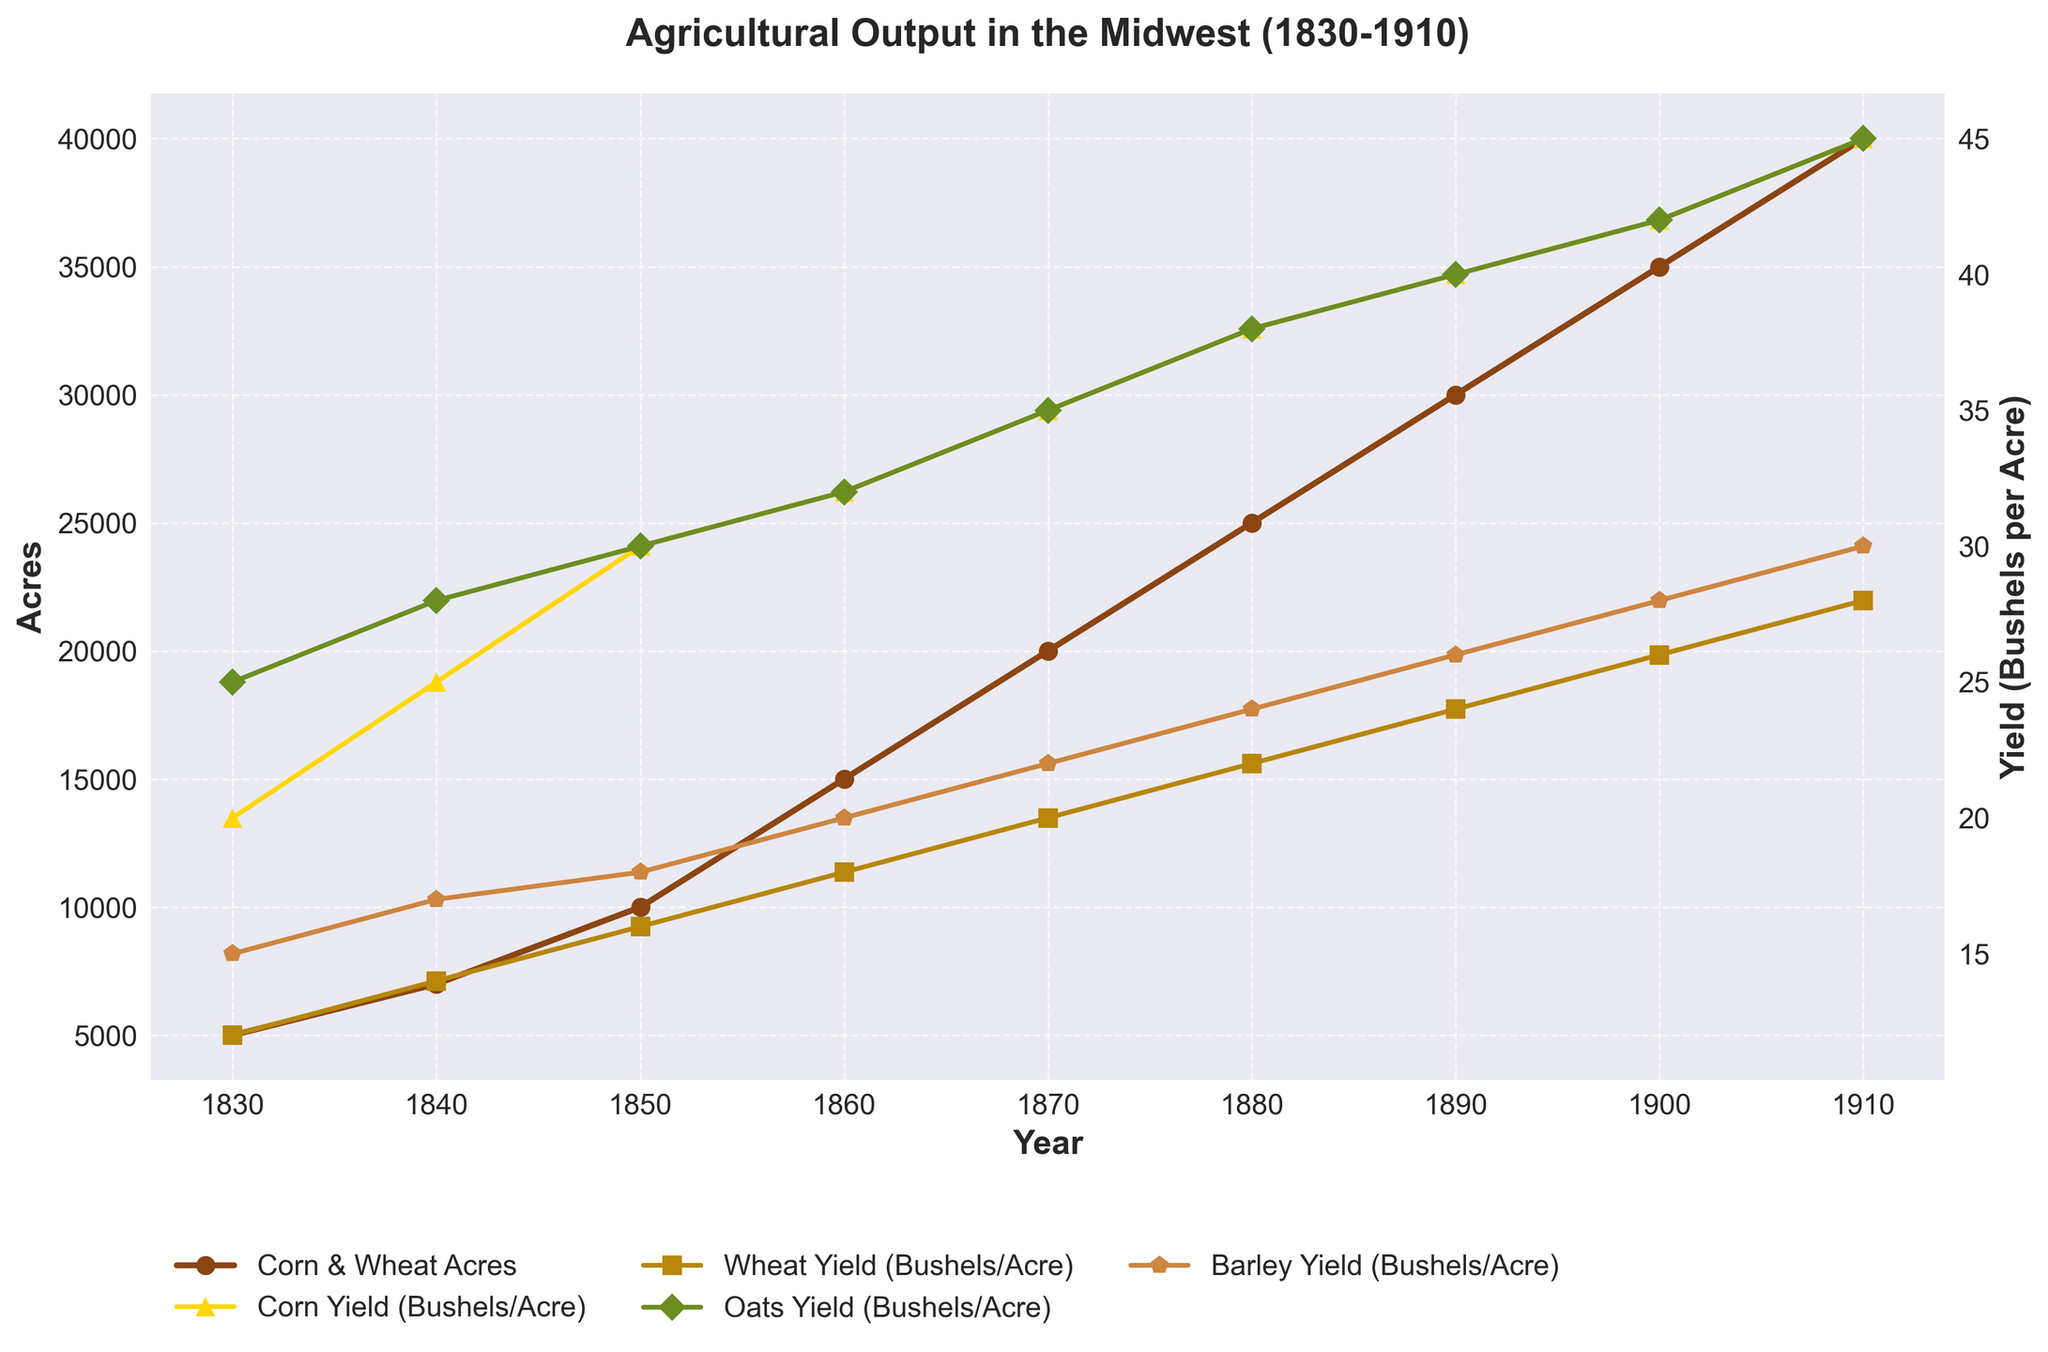What's the title of the figure? The title of the figure is prominently displayed at the top. The title is "Agricultural Output in the Midwest (1830-1910)".
Answer: Agricultural Output in the Midwest (1830-1910) How many acres were dedicated to Corn & Wheat in 1880? Look at the 'Corn & Wheat Acres' line and locate the year 1880 on the x-axis. Track vertically to find the corresponding y-value which is 25000 acres.
Answer: 25000 What were the yields of Corn and Wheat (in bushels per acre) in 1900? Track the curves for Corn Yield and Wheat Yield to the year 1900. The Corn Yield is 42 bushels per acre and the Wheat Yield is 26 bushels per acre.
Answer: Corn: 42, Wheat: 26 In which year did Oats Yield reach 45 bushels per acre? Follow the 'Oats Yield' line until it reaches 45 bushels per acre on the y-axis. This occurs in the year 1910.
Answer: 1910 Which crop had the highest yield in 1890? Compare the yield lines for Corn, Wheat, Oats, and Barley in 1890. The Corn Yield reaches the highest value of 40 bushels per acre.
Answer: Corn By how much did the Corn & Wheat Acres increase from 1830 to 1910? Subtract the value in 1830 (5000 acres) from the value in 1910 (40000 acres). The increase is 40000 - 5000 = 35000 acres.
Answer: 35000 What is the average yield of Barley over the entire period 1830-1910? Sum the Barley Yields (15, 17, 18, 20, 22, 24, 26, 28, 30) and divide by the number of years (9). The average yield is (15+17+18+20+22+24+26+28+30)/9 = 22.2 bushels per acre.
Answer: 22.2 Compare the trend of Corn Yield and Wheat Yield from 1830 to 1900. How do they differ? Observe that both Corn Yield and Wheat Yield show an upward trend, but Corn Yield increases at a faster rate, starting at 20 and reaching 42 by 1900, whereas Wheat Yield starts at 12 and reaches only 26 by 1900.
Answer: Corn yield increased faster What significant changes do you notice in agricultural output around 1860? Around 1860, there's a noticeable increase in both Corn & Wheat Acres and the yields of all crops (Corn Yield increased to 32, Wheat Yield to 18, Oats Yield to 32, and Barley Yield to 20). This suggests a significant improvement in agricultural practices or conditions.
Answer: Significant increase in acres and yields 